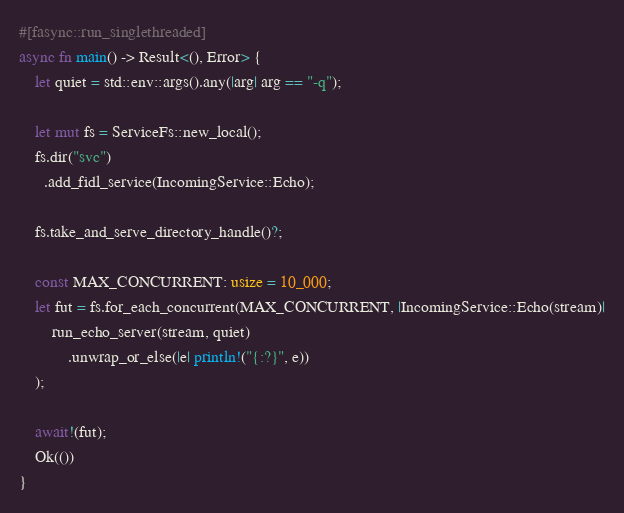Convert code to text. <code><loc_0><loc_0><loc_500><loc_500><_Rust_>#[fasync::run_singlethreaded]
async fn main() -> Result<(), Error> {
    let quiet = std::env::args().any(|arg| arg == "-q");

    let mut fs = ServiceFs::new_local();
    fs.dir("svc")
      .add_fidl_service(IncomingService::Echo);

    fs.take_and_serve_directory_handle()?;

    const MAX_CONCURRENT: usize = 10_000;
    let fut = fs.for_each_concurrent(MAX_CONCURRENT, |IncomingService::Echo(stream)|
        run_echo_server(stream, quiet)
            .unwrap_or_else(|e| println!("{:?}", e))
    );

    await!(fut);
    Ok(())
}
</code> 